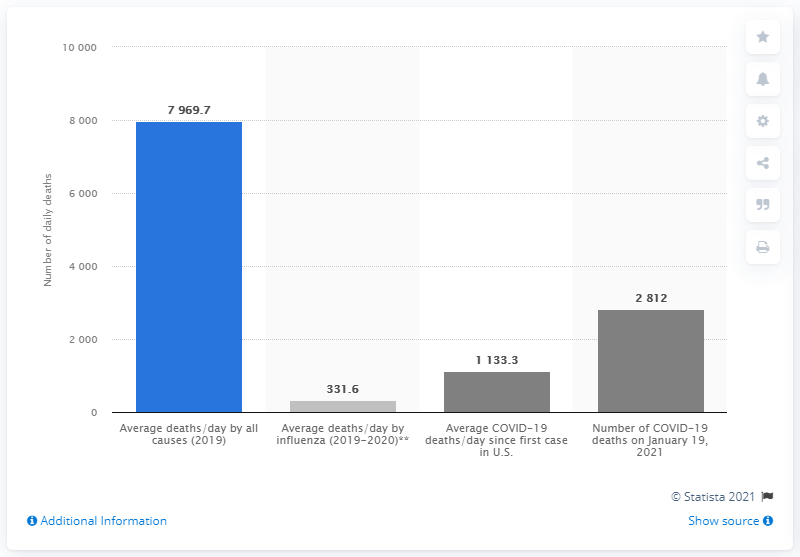Highlight a few significant elements in this photo. The highest bar in the graph represents the average number of deaths per day by all causes in 2019. Approximately 4.1% of total daily deaths are caused by influenza, on average. 